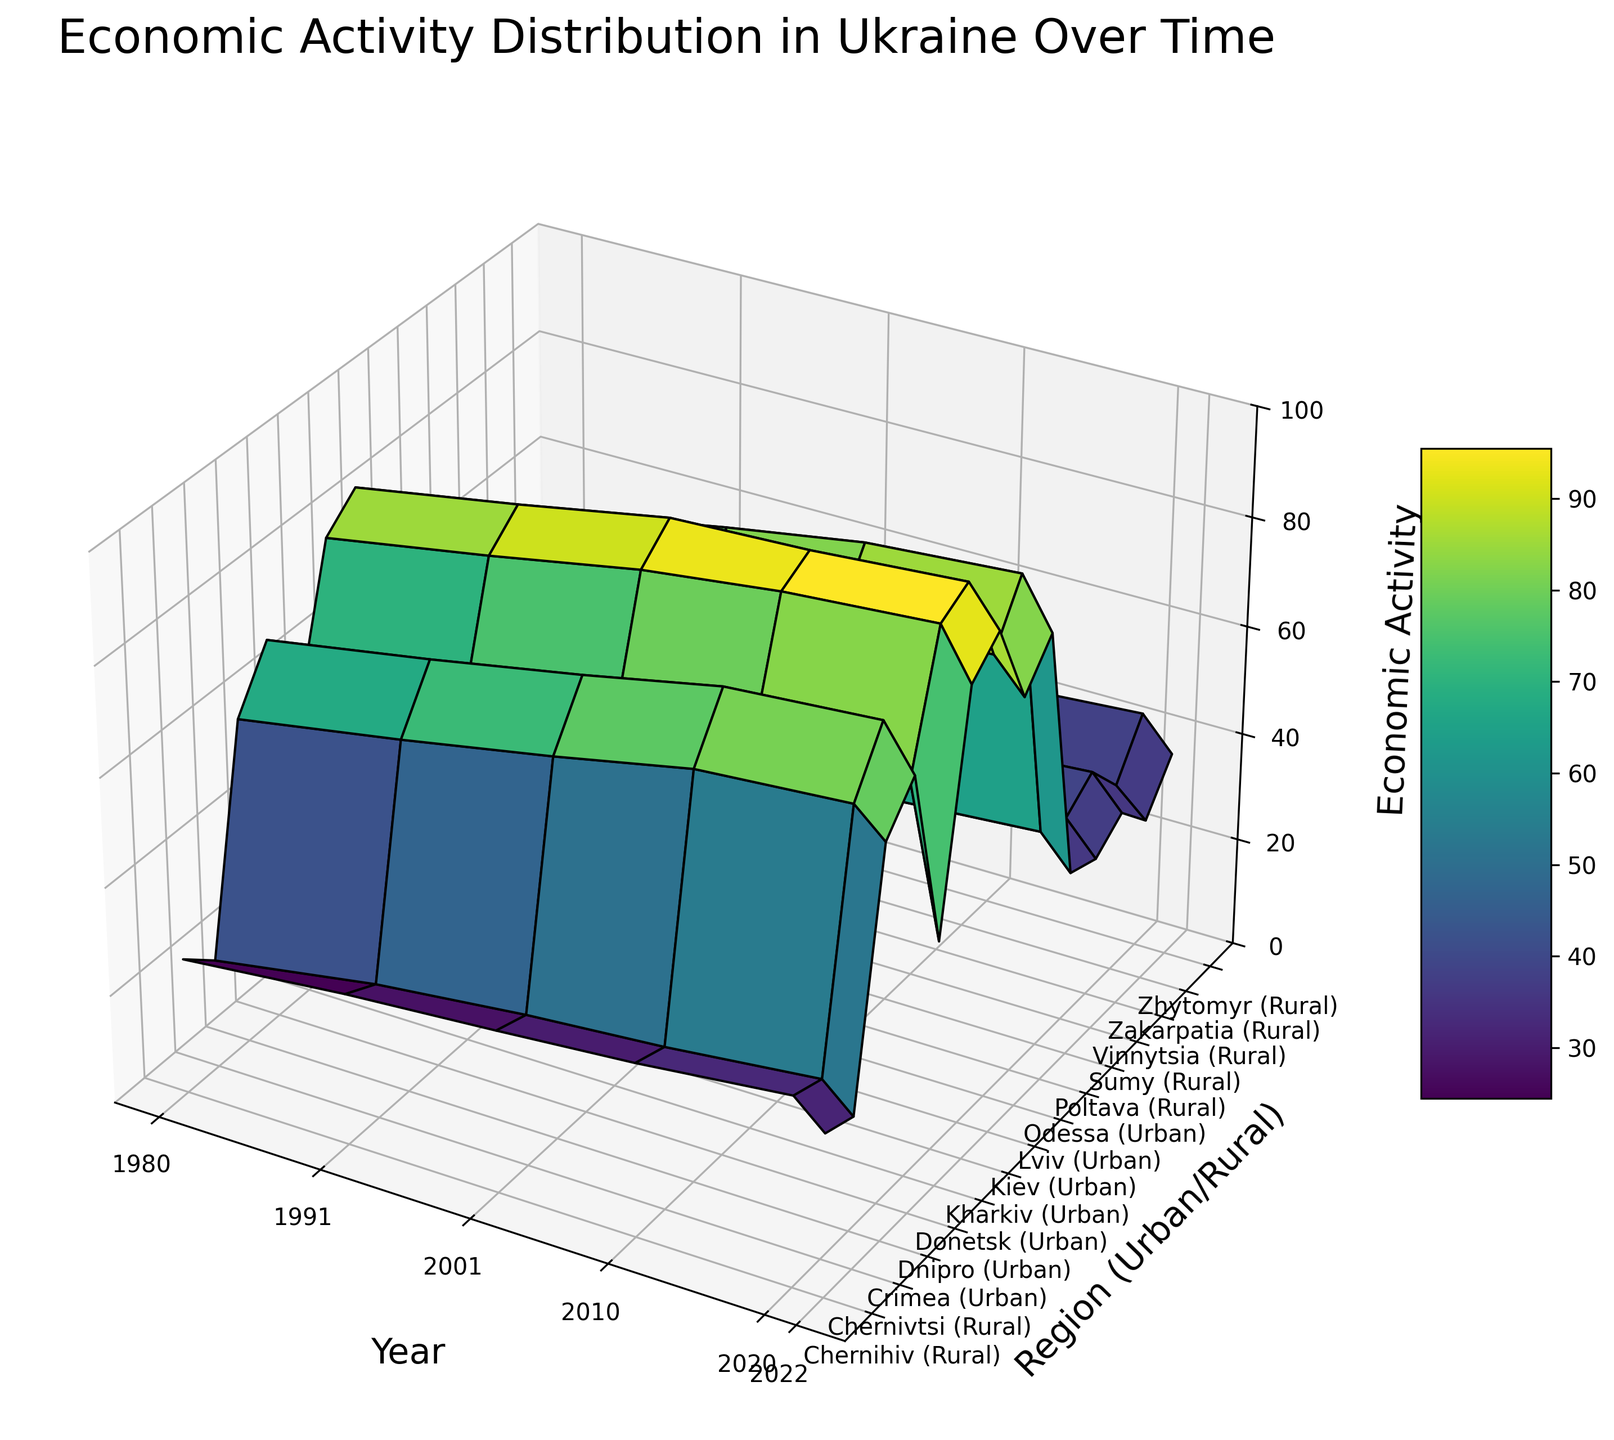Which region saw the highest economic activity in 2020? Look at the 2020 data for all regions and identify the highest peak in economic activity.
Answer: Kiev (Urban) How does the economic activity in rural areas of Zhytomyr in 1980 compare to 2020? Find the economic activity for rural Zhytomyr in 1980 and 2020, and compare them. In 1980, Zhytomyr had an economic activity of 35, and in 2020, it increased to 44.
Answer: Increased What is the difference in economic activity between urban Kiev and urban Donetsk in 2020? Check the economic activity for urban Kiev and urban Donetsk in 2020. Kiev has an activity of 98, while Donetsk has 72. The difference is 98 - 72.
Answer: 26 Which year showed the greatest disparity between urban and rural economic activity in Lviv? Compare the differences in economic activity between urban and rural Lviv across all years. The disparity in 1980, 1991, 2001, 2010, 2020, and 2022 can be calculated. The maximum disparity is in 1980 (65 - 20 = 45).
Answer: 1980 What trend can be observed in the economic activity of urban Kiev from 1980 to 2022? Observe the economic activity values for urban Kiev from 1980 (85), 1991 (90), 2001 (95), 2010 (96), 2020 (98), and 2022 (91). The trend shows an overall increase with a slight drop in 2022.
Answer: Increasing, slight drop in 2022 Compare the economic activity of rural Chernivtsi in 2001 and 2022. Find the values for rural Chernivtsi in 2001 and 2022 from the plot. In 2001, it was 28, and in 2022, it was also 28.
Answer: Same (28) Identify the year with the lowest economic activity in urban Donetsk. Examine the lowest point in the economic activity for urban Donetsk across all years. In 2022, it was at 45.
Answer: 2022 How has economic activity changed in rural Vinnytsia from 1980 to 2022? Observe the economic activity for rural Vinnytsia in 1980 (30) and then in 2022 (36). It has slightly increased.
Answer: Increased What is the average economic activity for urban Crimea across all years? Summarize the economic activity for urban Crimea across 1980 (60), 1991 (65), 2001 (70), 2010 (75), 2020 (77), and 2022 (72). Calculate the average: (60 + 65 + 70 + 75 + 77 + 72) / 6 = 69.83
Answer: 69.83 Which region has shown more consistent economic activity growth: urban Kharkiv or urban Odessa? Compare the incremental growth in economic activity of urban Kharkiv and urban Odessa over the years to determine consistency. Kharkiv shows a steady increase from 80 (1980) to 95 (2020) while Odessa from 75 (1980) to 91 (2020). However, Kharkiv has a more consistent and larger growth.
Answer: Urban Kharkiv 